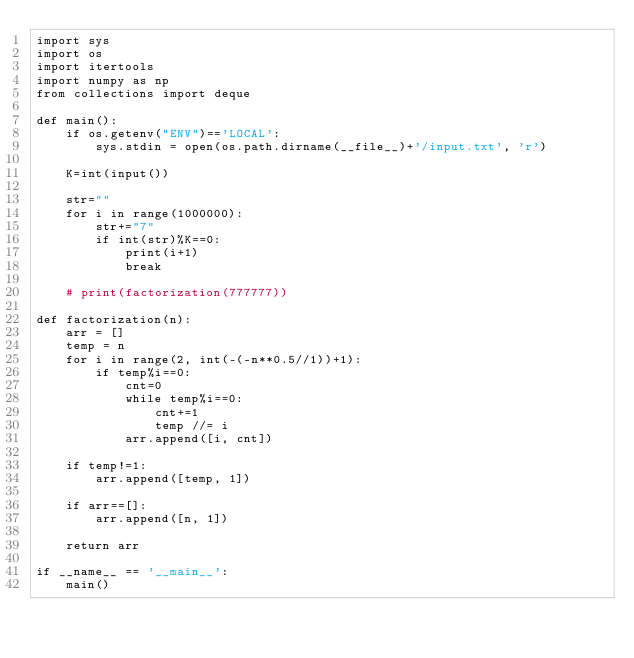<code> <loc_0><loc_0><loc_500><loc_500><_Python_>import sys
import os
import itertools
import numpy as np
from collections import deque

def main():
    if os.getenv("ENV")=='LOCAL':
        sys.stdin = open(os.path.dirname(__file__)+'/input.txt', 'r')

    K=int(input())

    str=""
    for i in range(1000000):
        str+="7"
        if int(str)%K==0:
            print(i+1)
            break

    # print(factorization(777777))

def factorization(n):
    arr = []
    temp = n
    for i in range(2, int(-(-n**0.5//1))+1):
        if temp%i==0:
            cnt=0
            while temp%i==0:
                cnt+=1
                temp //= i
            arr.append([i, cnt])

    if temp!=1:
        arr.append([temp, 1])

    if arr==[]:
        arr.append([n, 1])

    return arr

if __name__ == '__main__':
    main()
</code> 